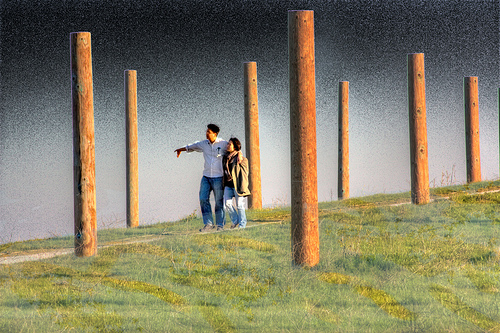<image>
Is there a people in front of the horizon? No. The people is not in front of the horizon. The spatial positioning shows a different relationship between these objects. Is there a people in front of the post? No. The people is not in front of the post. The spatial positioning shows a different relationship between these objects. 